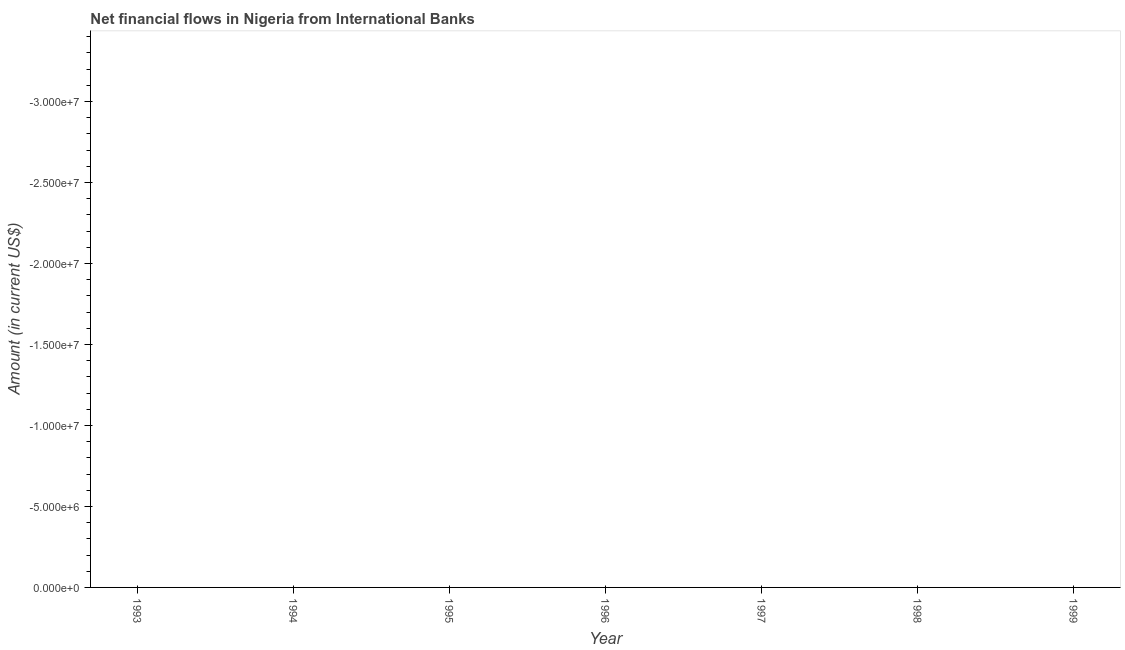What is the net financial flows from ibrd in 1995?
Keep it short and to the point. 0. Across all years, what is the minimum net financial flows from ibrd?
Offer a terse response. 0. In how many years, is the net financial flows from ibrd greater than the average net financial flows from ibrd taken over all years?
Your answer should be very brief. 0. How many dotlines are there?
Provide a succinct answer. 0. How many years are there in the graph?
Provide a short and direct response. 7. Are the values on the major ticks of Y-axis written in scientific E-notation?
Your answer should be very brief. Yes. Does the graph contain grids?
Your answer should be very brief. No. What is the title of the graph?
Your response must be concise. Net financial flows in Nigeria from International Banks. What is the Amount (in current US$) in 1994?
Your response must be concise. 0. What is the Amount (in current US$) in 1995?
Provide a short and direct response. 0. What is the Amount (in current US$) in 1996?
Offer a terse response. 0. What is the Amount (in current US$) in 1997?
Make the answer very short. 0. What is the Amount (in current US$) in 1998?
Your response must be concise. 0. 